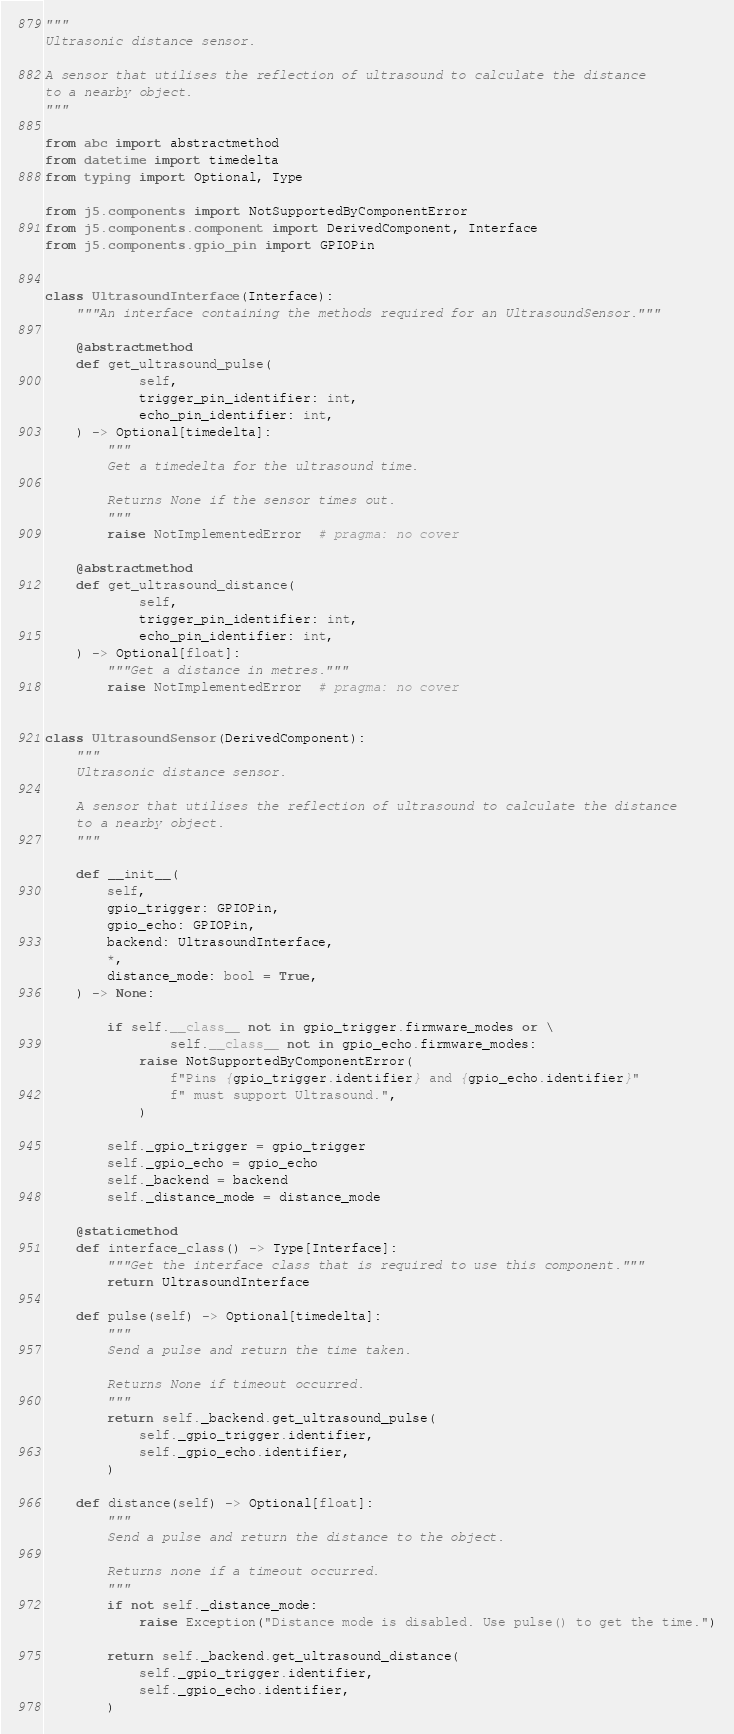Convert code to text. <code><loc_0><loc_0><loc_500><loc_500><_Python_>"""
Ultrasonic distance sensor.

A sensor that utilises the reflection of ultrasound to calculate the distance
to a nearby object.
"""

from abc import abstractmethod
from datetime import timedelta
from typing import Optional, Type

from j5.components import NotSupportedByComponentError
from j5.components.component import DerivedComponent, Interface
from j5.components.gpio_pin import GPIOPin


class UltrasoundInterface(Interface):
    """An interface containing the methods required for an UltrasoundSensor."""

    @abstractmethod
    def get_ultrasound_pulse(
            self,
            trigger_pin_identifier: int,
            echo_pin_identifier: int,
    ) -> Optional[timedelta]:
        """
        Get a timedelta for the ultrasound time.

        Returns None if the sensor times out.
        """
        raise NotImplementedError  # pragma: no cover

    @abstractmethod
    def get_ultrasound_distance(
            self,
            trigger_pin_identifier: int,
            echo_pin_identifier: int,
    ) -> Optional[float]:
        """Get a distance in metres."""
        raise NotImplementedError  # pragma: no cover


class UltrasoundSensor(DerivedComponent):
    """
    Ultrasonic distance sensor.

    A sensor that utilises the reflection of ultrasound to calculate the distance
    to a nearby object.
    """

    def __init__(
        self,
        gpio_trigger: GPIOPin,
        gpio_echo: GPIOPin,
        backend: UltrasoundInterface,
        *,
        distance_mode: bool = True,
    ) -> None:

        if self.__class__ not in gpio_trigger.firmware_modes or \
                self.__class__ not in gpio_echo.firmware_modes:
            raise NotSupportedByComponentError(
                f"Pins {gpio_trigger.identifier} and {gpio_echo.identifier}"
                f" must support Ultrasound.",
            )

        self._gpio_trigger = gpio_trigger
        self._gpio_echo = gpio_echo
        self._backend = backend
        self._distance_mode = distance_mode

    @staticmethod
    def interface_class() -> Type[Interface]:
        """Get the interface class that is required to use this component."""
        return UltrasoundInterface

    def pulse(self) -> Optional[timedelta]:
        """
        Send a pulse and return the time taken.

        Returns None if timeout occurred.
        """
        return self._backend.get_ultrasound_pulse(
            self._gpio_trigger.identifier,
            self._gpio_echo.identifier,
        )

    def distance(self) -> Optional[float]:
        """
        Send a pulse and return the distance to the object.

        Returns none if a timeout occurred.
        """
        if not self._distance_mode:
            raise Exception("Distance mode is disabled. Use pulse() to get the time.")

        return self._backend.get_ultrasound_distance(
            self._gpio_trigger.identifier,
            self._gpio_echo.identifier,
        )
</code> 